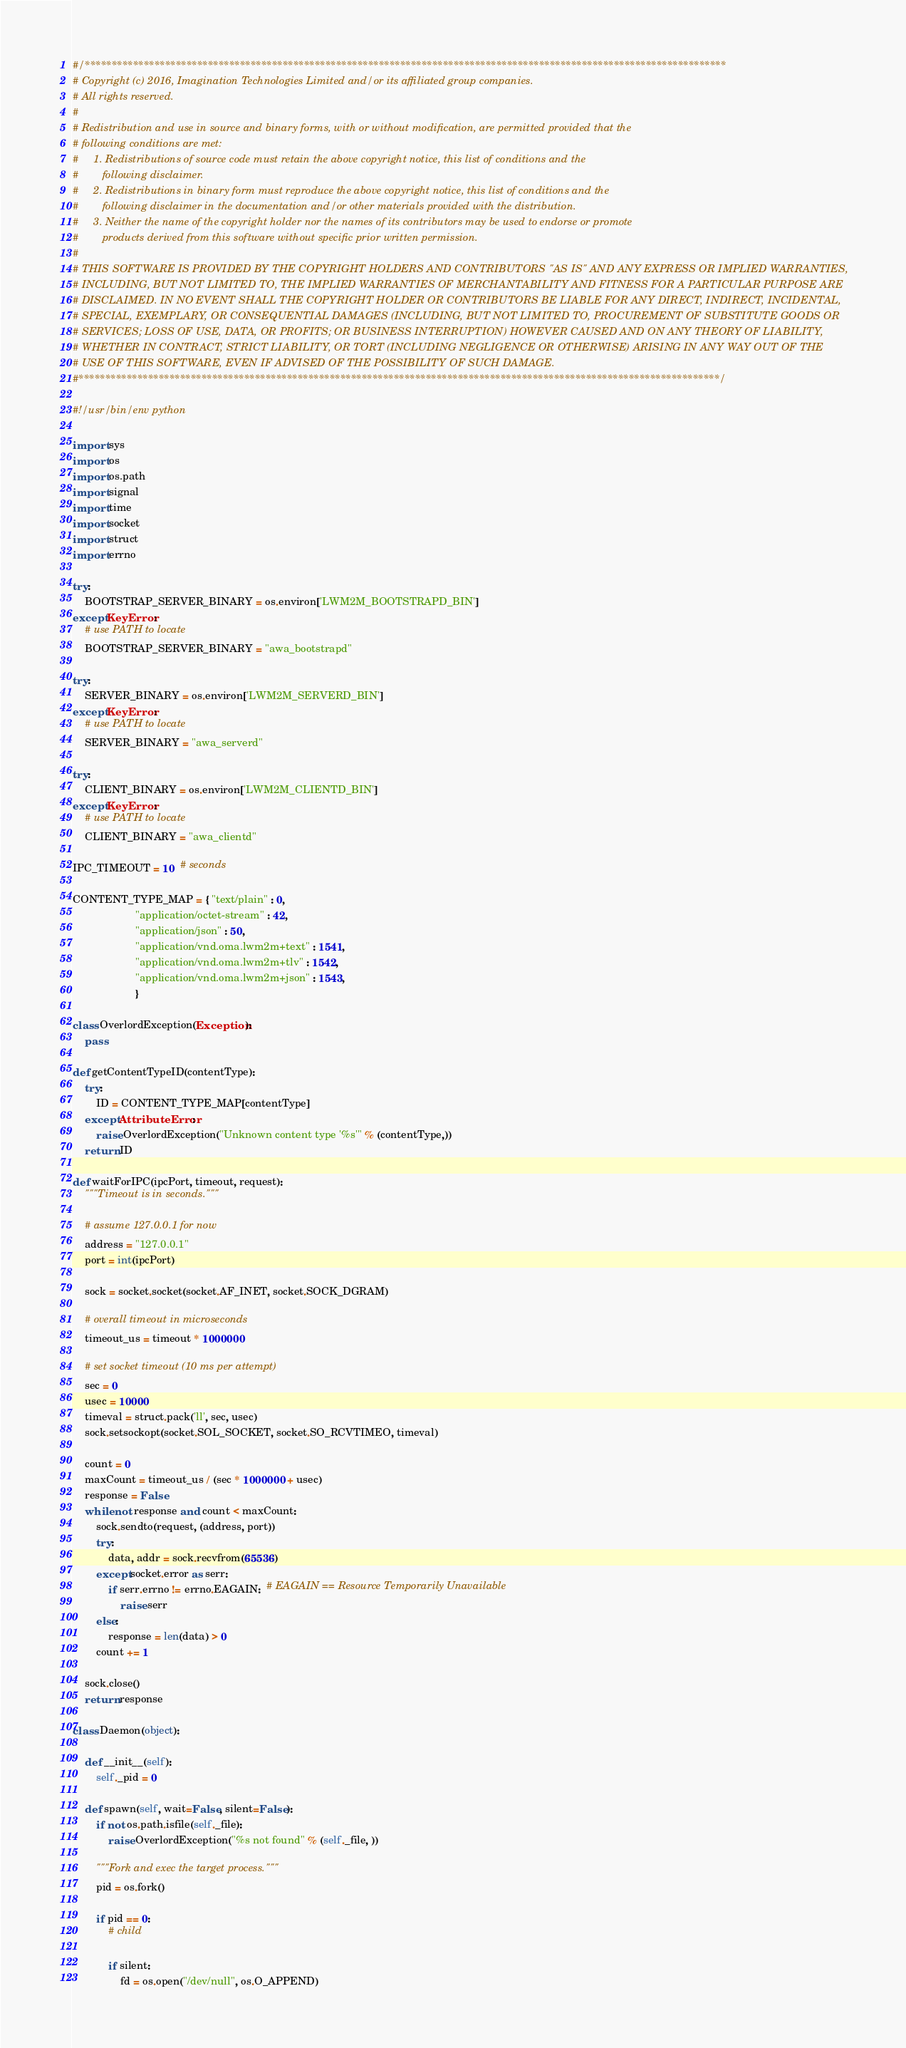Convert code to text. <code><loc_0><loc_0><loc_500><loc_500><_Python_>#/************************************************************************************************************************
# Copyright (c) 2016, Imagination Technologies Limited and/or its affiliated group companies.
# All rights reserved.
#
# Redistribution and use in source and binary forms, with or without modification, are permitted provided that the
# following conditions are met:
#     1. Redistributions of source code must retain the above copyright notice, this list of conditions and the
#        following disclaimer.
#     2. Redistributions in binary form must reproduce the above copyright notice, this list of conditions and the
#        following disclaimer in the documentation and/or other materials provided with the distribution.
#     3. Neither the name of the copyright holder nor the names of its contributors may be used to endorse or promote
#        products derived from this software without specific prior written permission.
#
# THIS SOFTWARE IS PROVIDED BY THE COPYRIGHT HOLDERS AND CONTRIBUTORS "AS IS" AND ANY EXPRESS OR IMPLIED WARRANTIES,
# INCLUDING, BUT NOT LIMITED TO, THE IMPLIED WARRANTIES OF MERCHANTABILITY AND FITNESS FOR A PARTICULAR PURPOSE ARE
# DISCLAIMED. IN NO EVENT SHALL THE COPYRIGHT HOLDER OR CONTRIBUTORS BE LIABLE FOR ANY DIRECT, INDIRECT, INCIDENTAL, 
# SPECIAL, EXEMPLARY, OR CONSEQUENTIAL DAMAGES (INCLUDING, BUT NOT LIMITED TO, PROCUREMENT OF SUBSTITUTE GOODS OR
# SERVICES; LOSS OF USE, DATA, OR PROFITS; OR BUSINESS INTERRUPTION) HOWEVER CAUSED AND ON ANY THEORY OF LIABILITY, 
# WHETHER IN CONTRACT, STRICT LIABILITY, OR TORT (INCLUDING NEGLIGENCE OR OTHERWISE) ARISING IN ANY WAY OUT OF THE 
# USE OF THIS SOFTWARE, EVEN IF ADVISED OF THE POSSIBILITY OF SUCH DAMAGE.
#************************************************************************************************************************/

#!/usr/bin/env python

import sys
import os
import os.path
import signal
import time
import socket
import struct
import errno

try:
    BOOTSTRAP_SERVER_BINARY = os.environ['LWM2M_BOOTSTRAPD_BIN']
except KeyError:
    # use PATH to locate
    BOOTSTRAP_SERVER_BINARY = "awa_bootstrapd"

try:
    SERVER_BINARY = os.environ['LWM2M_SERVERD_BIN']
except KeyError:
    # use PATH to locate
    SERVER_BINARY = "awa_serverd"

try:
    CLIENT_BINARY = os.environ['LWM2M_CLIENTD_BIN']
except KeyError:
    # use PATH to locate
    CLIENT_BINARY = "awa_clientd"

IPC_TIMEOUT = 10  # seconds

CONTENT_TYPE_MAP = { "text/plain" : 0,
                     "application/octet-stream" : 42,
                     "application/json" : 50,
                     "application/vnd.oma.lwm2m+text" : 1541,
                     "application/vnd.oma.lwm2m+tlv" : 1542,
                     "application/vnd.oma.lwm2m+json" : 1543,
                     }

class OverlordException(Exception):
    pass

def getContentTypeID(contentType):
    try:
        ID = CONTENT_TYPE_MAP[contentType]
    except AttributeError:
        raise OverlordException("Unknown content type '%s'" % (contentType,))
    return ID

def waitForIPC(ipcPort, timeout, request):
    """Timeout is in seconds."""

    # assume 127.0.0.1 for now
    address = "127.0.0.1"
    port = int(ipcPort)

    sock = socket.socket(socket.AF_INET, socket.SOCK_DGRAM)

    # overall timeout in microseconds
    timeout_us = timeout * 1000000

    # set socket timeout (10 ms per attempt)
    sec = 0
    usec = 10000
    timeval = struct.pack('ll', sec, usec)
    sock.setsockopt(socket.SOL_SOCKET, socket.SO_RCVTIMEO, timeval)

    count = 0
    maxCount = timeout_us / (sec * 1000000 + usec)
    response = False
    while not response and count < maxCount:
        sock.sendto(request, (address, port))
        try:
            data, addr = sock.recvfrom(65536)
        except socket.error as serr:
            if serr.errno != errno.EAGAIN:  # EAGAIN == Resource Temporarily Unavailable
                raise serr
        else:
            response = len(data) > 0
        count += 1

    sock.close()
    return response

class Daemon(object):

    def __init__(self):
        self._pid = 0

    def spawn(self, wait=False, silent=False):
        if not os.path.isfile(self._file):
            raise OverlordException("%s not found" % (self._file, ))

        """Fork and exec the target process."""
        pid = os.fork()

        if pid == 0:
            # child

            if silent:
                fd = os.open("/dev/null", os.O_APPEND)</code> 